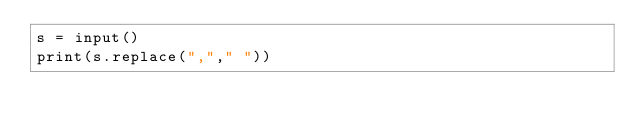Convert code to text. <code><loc_0><loc_0><loc_500><loc_500><_Python_>s = input()
print(s.replace(","," "))</code> 